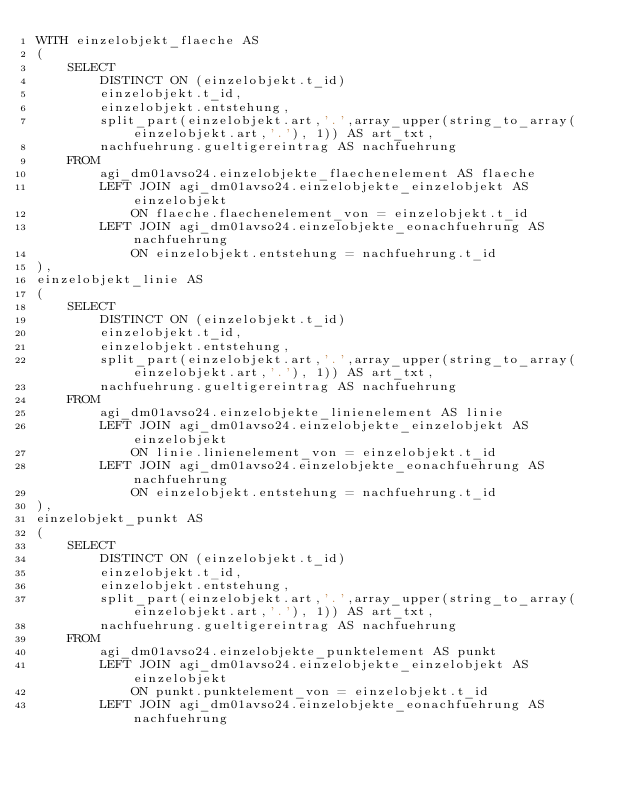<code> <loc_0><loc_0><loc_500><loc_500><_SQL_>WITH einzelobjekt_flaeche AS
(
    SELECT
        DISTINCT ON (einzelobjekt.t_id)    
        einzelobjekt.t_id,
        einzelobjekt.entstehung,
        split_part(einzelobjekt.art,'.',array_upper(string_to_array(einzelobjekt.art,'.'), 1)) AS art_txt,
    	nachfuehrung.gueltigereintrag AS nachfuehrung
    FROM
        agi_dm01avso24.einzelobjekte_flaechenelement AS flaeche
        LEFT JOIN agi_dm01avso24.einzelobjekte_einzelobjekt AS einzelobjekt
            ON flaeche.flaechenelement_von = einzelobjekt.t_id
        LEFT JOIN agi_dm01avso24.einzelobjekte_eonachfuehrung AS nachfuehrung
            ON einzelobjekt.entstehung = nachfuehrung.t_id
),
einzelobjekt_linie AS
(
    SELECT
        DISTINCT ON (einzelobjekt.t_id)
        einzelobjekt.t_id,
        einzelobjekt.entstehung,
        split_part(einzelobjekt.art,'.',array_upper(string_to_array(einzelobjekt.art,'.'), 1)) AS art_txt,
    	nachfuehrung.gueltigereintrag AS nachfuehrung
    FROM
        agi_dm01avso24.einzelobjekte_linienelement AS linie
        LEFT JOIN agi_dm01avso24.einzelobjekte_einzelobjekt AS einzelobjekt
            ON linie.linienelement_von = einzelobjekt.t_id
        LEFT JOIN agi_dm01avso24.einzelobjekte_eonachfuehrung AS nachfuehrung
            ON einzelobjekt.entstehung = nachfuehrung.t_id
),
einzelobjekt_punkt AS
(
    SELECT
        DISTINCT ON (einzelobjekt.t_id)
        einzelobjekt.t_id,
        einzelobjekt.entstehung,
        split_part(einzelobjekt.art,'.',array_upper(string_to_array(einzelobjekt.art,'.'), 1)) AS art_txt,
    	nachfuehrung.gueltigereintrag AS nachfuehrung
    FROM
        agi_dm01avso24.einzelobjekte_punktelement AS punkt
        LEFT JOIN agi_dm01avso24.einzelobjekte_einzelobjekt AS einzelobjekt
            ON punkt.punktelement_von = einzelobjekt.t_id
        LEFT JOIN agi_dm01avso24.einzelobjekte_eonachfuehrung AS nachfuehrung</code> 